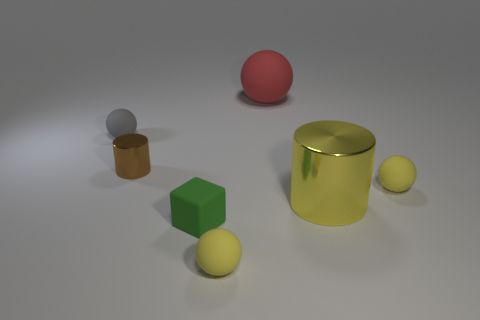Do the cylinder on the left side of the large yellow metal thing and the cylinder on the right side of the small green cube have the same size?
Your answer should be very brief. No. What number of things are large blue rubber blocks or small green matte objects?
Make the answer very short. 1. How big is the shiny cylinder right of the brown cylinder?
Ensure brevity in your answer.  Large. There is a metal cylinder on the right side of the tiny rubber ball that is in front of the tiny block; how many green things are to the left of it?
Provide a succinct answer. 1. How many objects are both right of the tiny cylinder and in front of the gray ball?
Your answer should be very brief. 4. What shape is the small thing to the left of the tiny cylinder?
Your response must be concise. Sphere. Is the number of large red matte objects in front of the gray object less than the number of big yellow things that are left of the big yellow metallic cylinder?
Your answer should be very brief. No. Does the yellow ball that is behind the small green cube have the same material as the ball that is behind the gray matte thing?
Your response must be concise. Yes. What shape is the small green rubber object?
Give a very brief answer. Cube. Is the number of small green objects that are on the right side of the small green matte thing greater than the number of brown things behind the large red sphere?
Your response must be concise. No. 